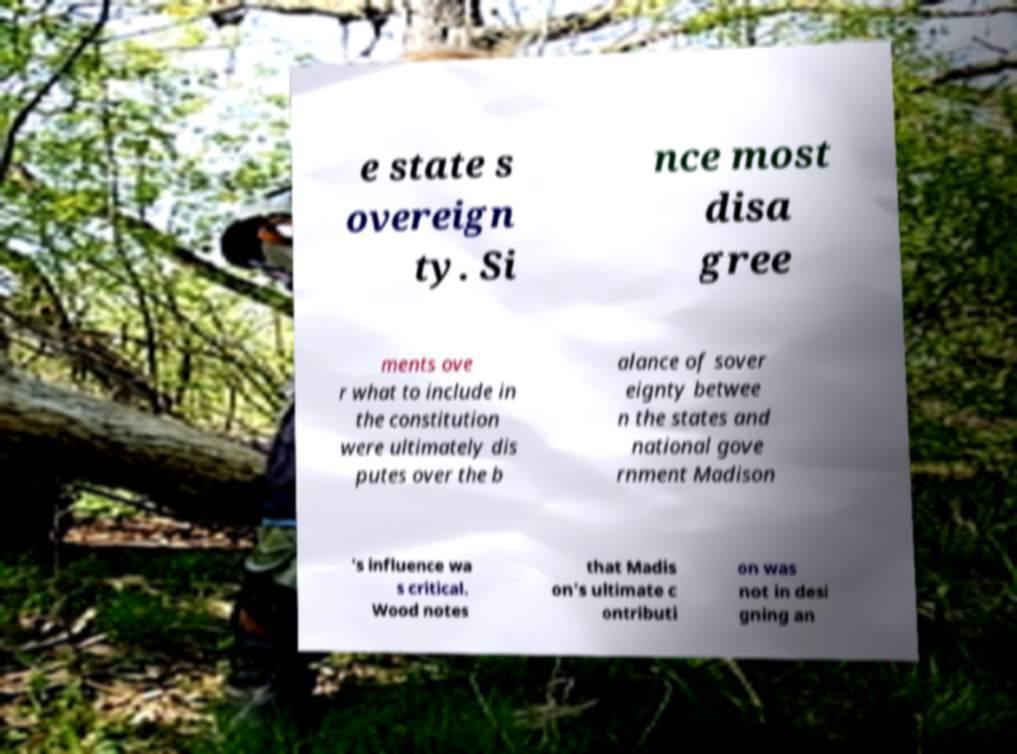What messages or text are displayed in this image? I need them in a readable, typed format. e state s overeign ty. Si nce most disa gree ments ove r what to include in the constitution were ultimately dis putes over the b alance of sover eignty betwee n the states and national gove rnment Madison 's influence wa s critical. Wood notes that Madis on's ultimate c ontributi on was not in desi gning an 